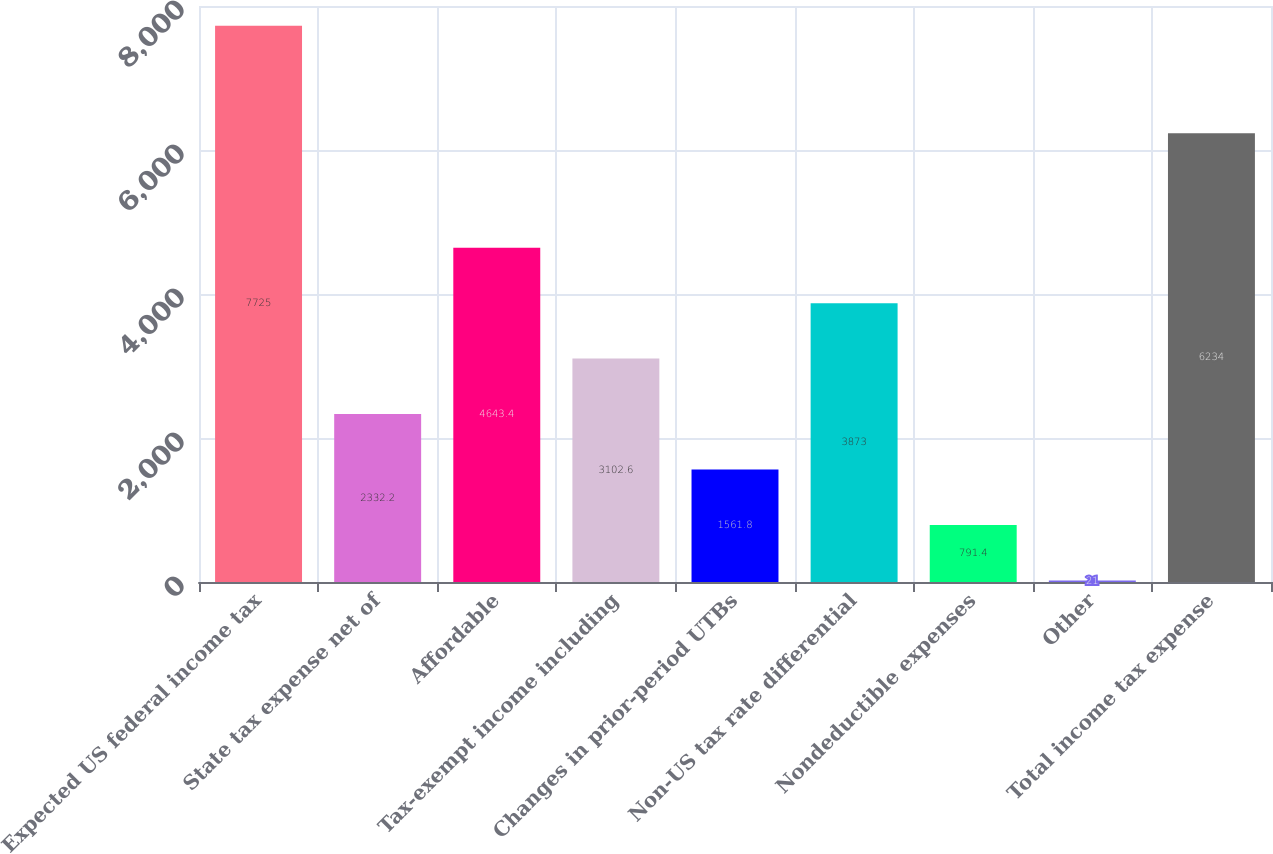Convert chart. <chart><loc_0><loc_0><loc_500><loc_500><bar_chart><fcel>Expected US federal income tax<fcel>State tax expense net of<fcel>Affordable<fcel>Tax-exempt income including<fcel>Changes in prior-period UTBs<fcel>Non-US tax rate differential<fcel>Nondeductible expenses<fcel>Other<fcel>Total income tax expense<nl><fcel>7725<fcel>2332.2<fcel>4643.4<fcel>3102.6<fcel>1561.8<fcel>3873<fcel>791.4<fcel>21<fcel>6234<nl></chart> 